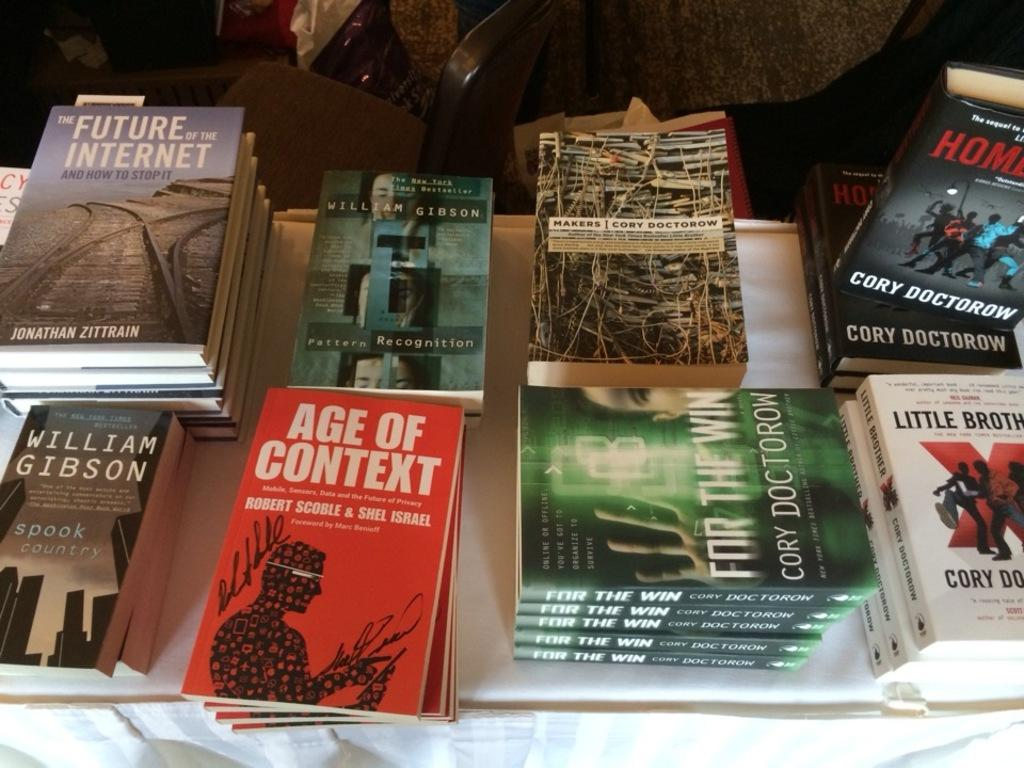<image>
Render a clear and concise summary of the photo. A selection of books including Age of Context and the Future of the Internet among others. 